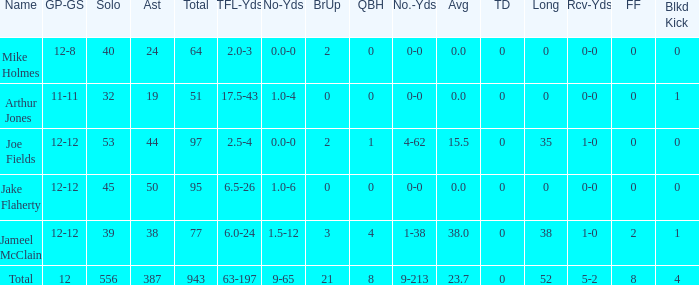How many tackle assists for the player who averages 23.7? 387.0. 